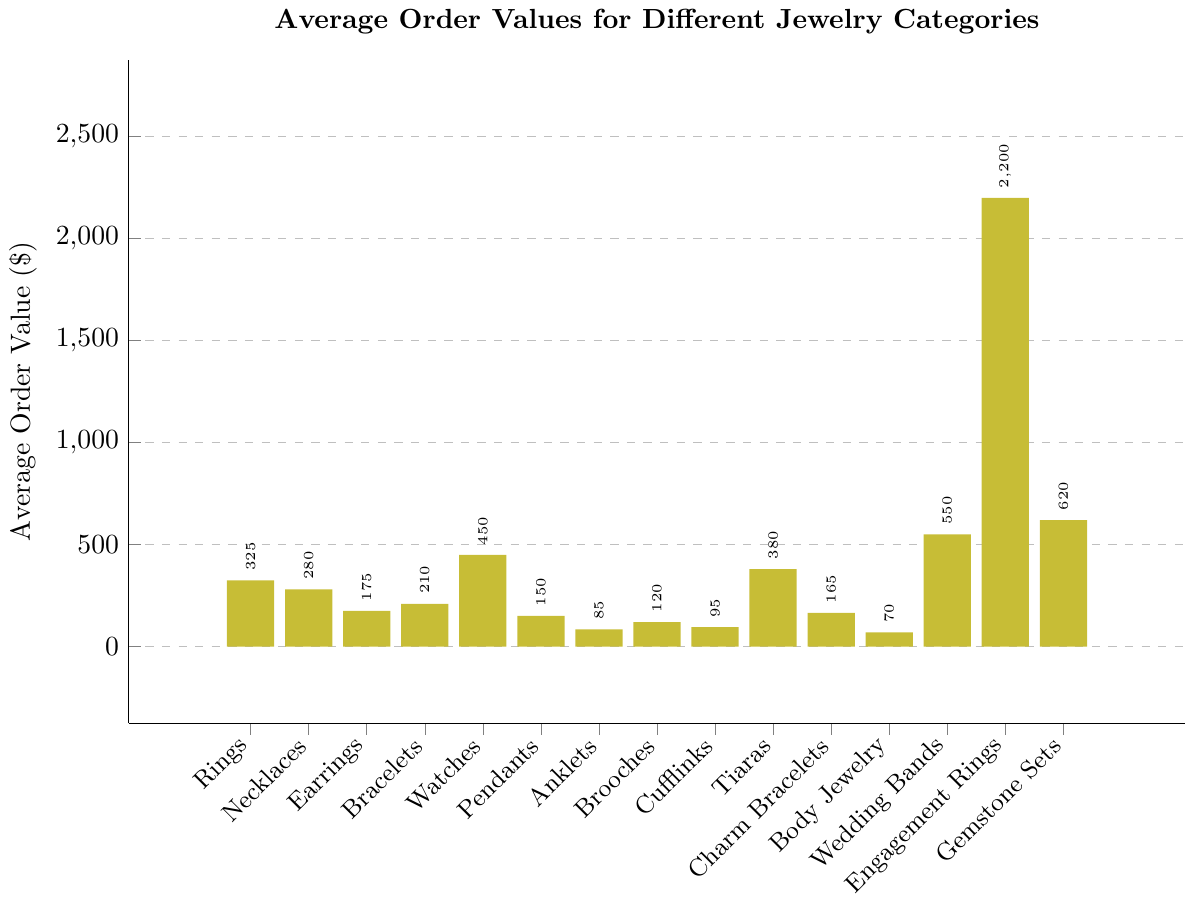What is the category with the highest average order value? Observe the bar representing engagement rings on the chart; it is the tallest, indicating the highest average order value.
Answer: Engagement Rings Which category has a higher average order value, tiaras or watches? Compare the heights of the bars for tiaras and watches. The bar for watches is taller, indicating a higher average order value.
Answer: Watches What is the total average order value of bracelets, pendants, and anklets combined? Add the values for bracelets ($210), pendants ($150), and anklets ($85): $210 + $150 + $85 = $445.
Answer: $445 How much higher is the average order value for gemstone sets compared to necklaces? Subtract the average order value of necklaces ($280) from that of gemstone sets ($620): $620 - $280 = $340.
Answer: $340 What percentage of the average order value of engagement rings is the order value of body jewelry? Divide the average order value of body jewelry ($70) by the value for engagement rings ($2200) and multiply by 100: ($70 / $2200) * 100 ≈ 3.18%.
Answer: ≈ 3.18% Between rings and brooches, which category has a higher average order value and by how much? Compare the bars for rings ($325) and brooches ($120). Rings have a higher value. Calculate the difference: $325 - $120 = $205.
Answer: Rings, $205 How do the average order values of tiaras and wedding bands compare? By what amount? The bar for wedding bands ($550) is taller than the one for tiaras ($380). Subtract the values: $550 - $380 = $170.
Answer: Wedding bands, $170 What is the median average order value of all the jewelry categories? Arrange the values in ascending order: 70, 85, 95, 120, 150, 165, 175, 210, 280, 325, 380, 450, 550, 620, 2200. The middle value is the 8th one in the list, which is $210.
Answer: $210 Do earrings or charm bracelets have a higher average order value? By what percentage? Compare earrings ($175) to charm bracelets ($165). Calculate the percentage difference: (($175 - $165) / $165) * 100 ≈ 6.06%.
Answer: Earrings, ≈ 6.06% How does the average order value of body jewelry compare to cufflinks? Compare the values: body jewelry ($70) and cufflinks ($95). Calculate the difference: $95 - $70 = $25.
Answer: Cufflinks, $25 